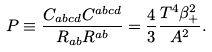<formula> <loc_0><loc_0><loc_500><loc_500>P \equiv \frac { C _ { a b c d } C ^ { a b c d } } { R _ { a b } R ^ { a b } } = \frac { 4 } { 3 } \frac { T ^ { 4 } \beta _ { + } ^ { 2 } } { A ^ { 2 } } .</formula> 